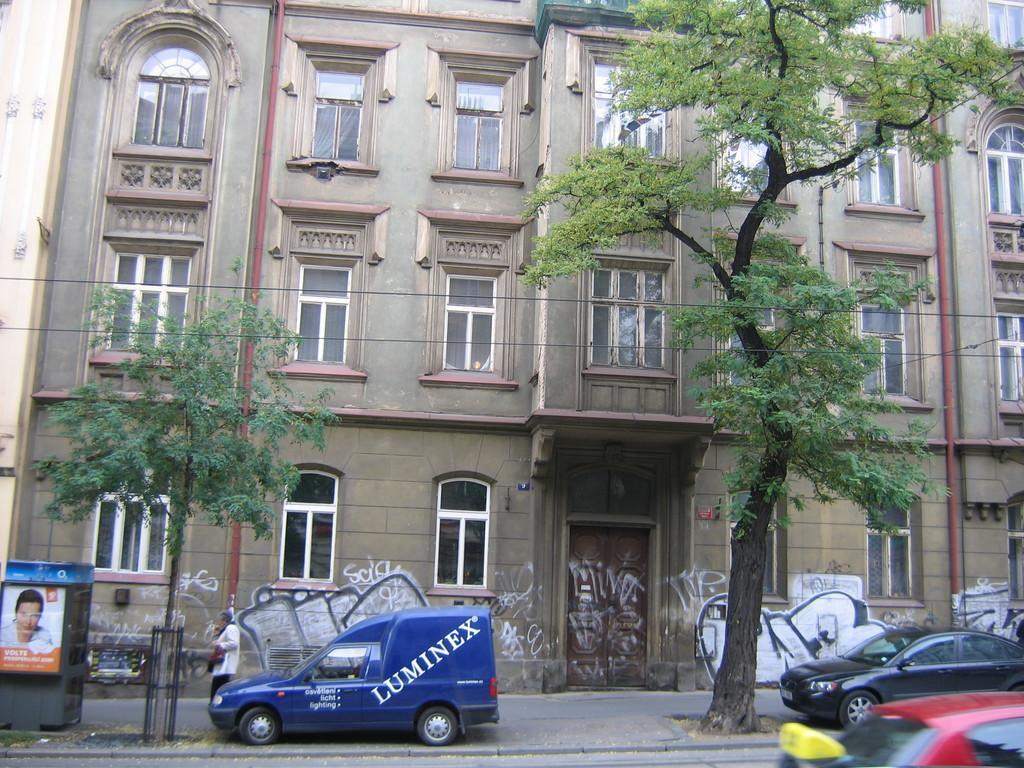Can you describe this image briefly? In this picture we can see a person is walking on the pathway, beside to the person we can find few vehicles on the road, and also we can see few trees, cables and a building. 